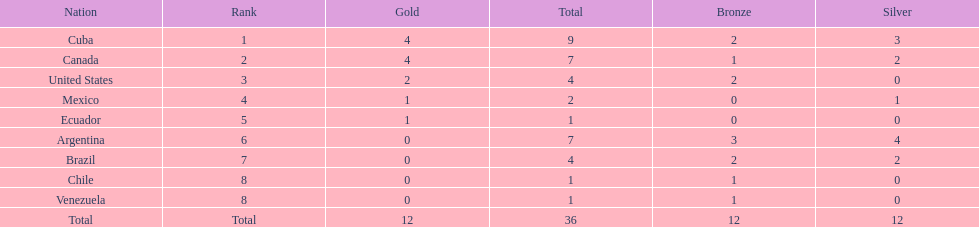How many total medals did brazil received? 4. 